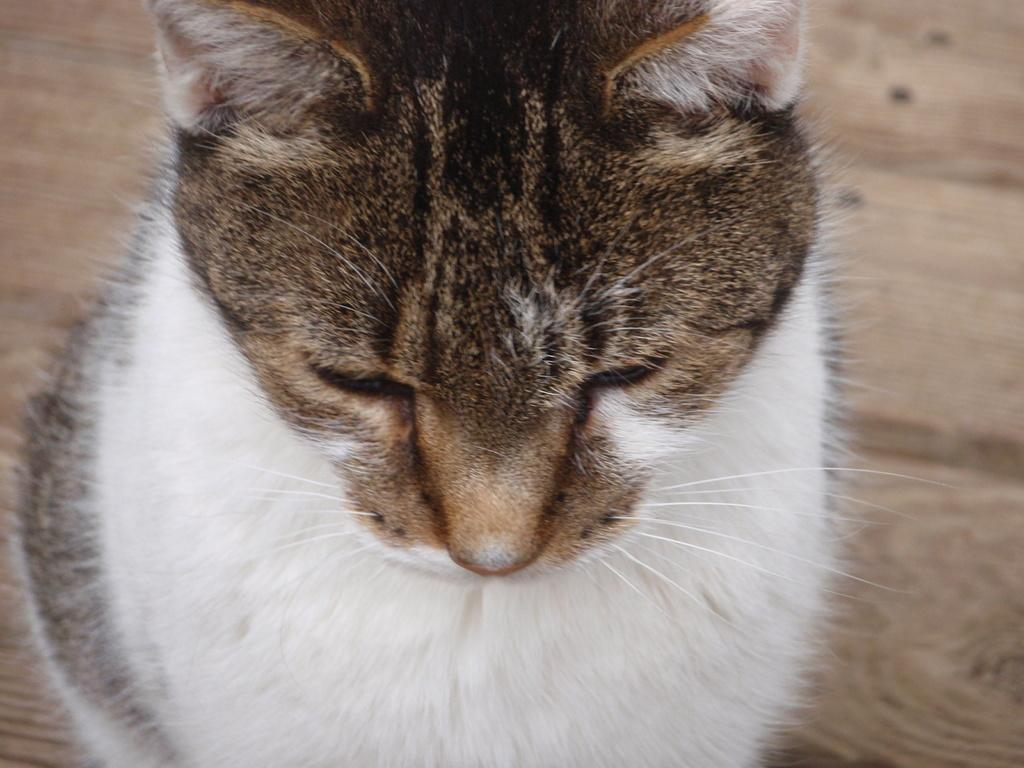What type of animal is in the image? There is a cat in the image. Can you describe the position of the cat in the image? The cat is in front. What type of flooring is visible at the bottom of the image? There is a wooden floor at the bottom of the image. What type of instrument is the cat playing in the image? There is no instrument present in the image, and the cat is not playing any instrument. What type of silk material can be seen in the image? There is no silk material present in the image. What type of stitch is visible on the cat's fur in the image? There is no stitch visible on the cat's fur in the image. 